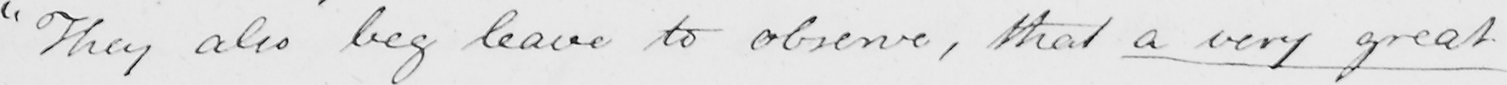Please transcribe the handwritten text in this image. " They also beg leave to observe , that a very great 